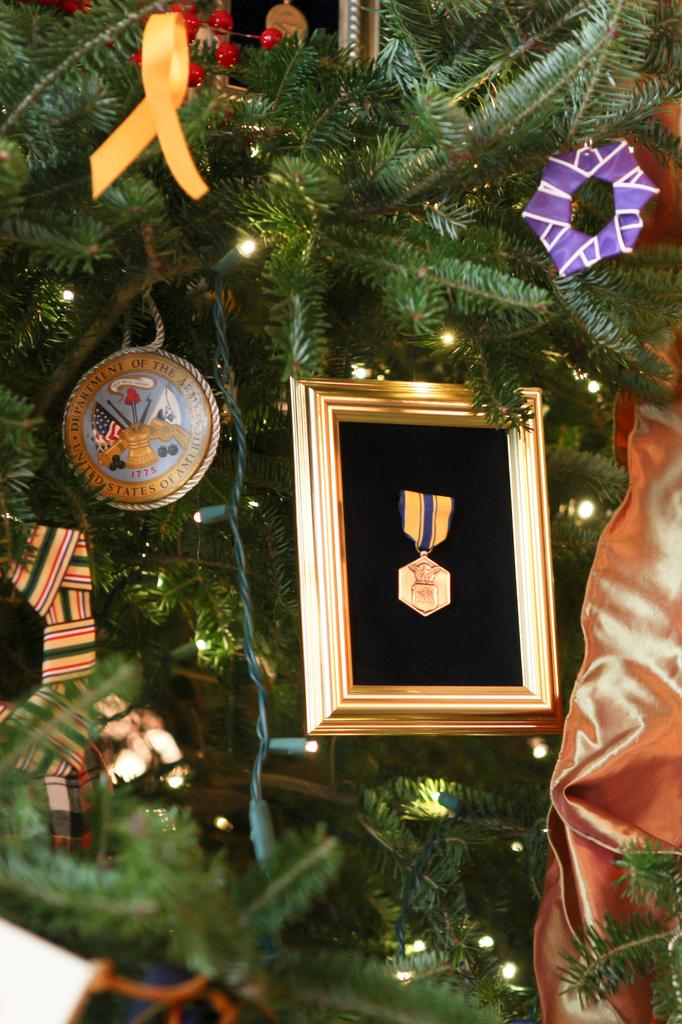What type of tree is in the image? There is a Christmas tree in the image. What else can be seen around the tree? There are decorative items in the image. What is in front of the tree? There is a frame in front of the tree. What can be seen in the background of the image? There are lights visible in the background of the image. What type of bait is used to catch fish in the image? There is no bait or fishing activity present in the image. What type of corn is growing in the image? There is no corn or agricultural activity present in the image. 